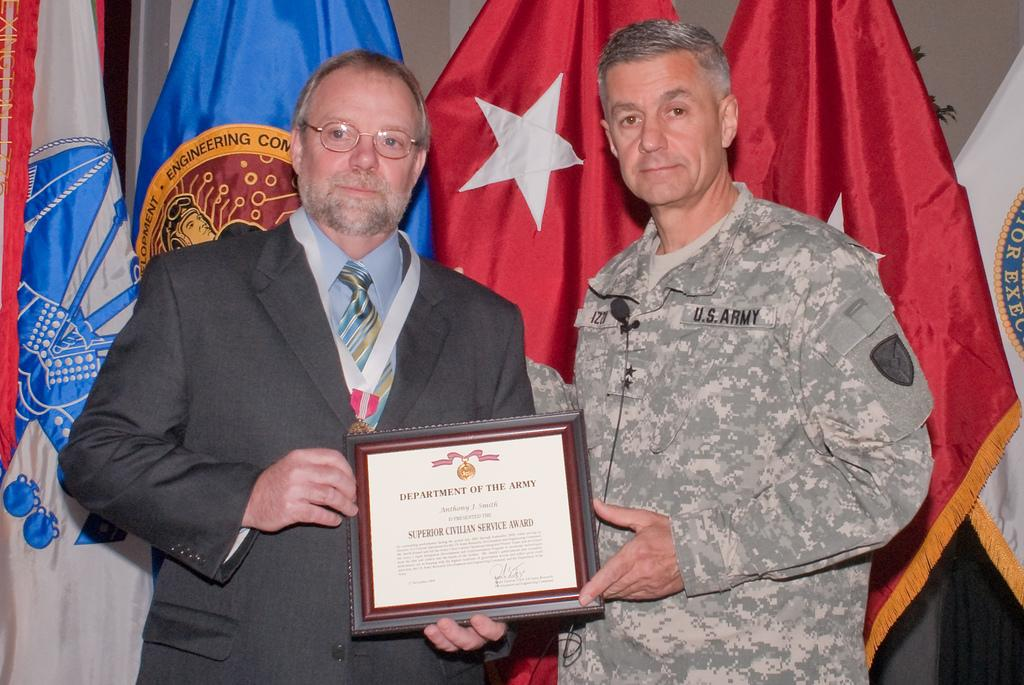What are the men in the image holding? The men in the image are holding a frame with text. What can be seen in the background of the image? There are flags visible in the background of the image. What type of table is being used by the men in the image? There is no table present in the image; the men are holding a frame with text. Can you see a trampoline in the image? No, there is no trampoline present in the image. 